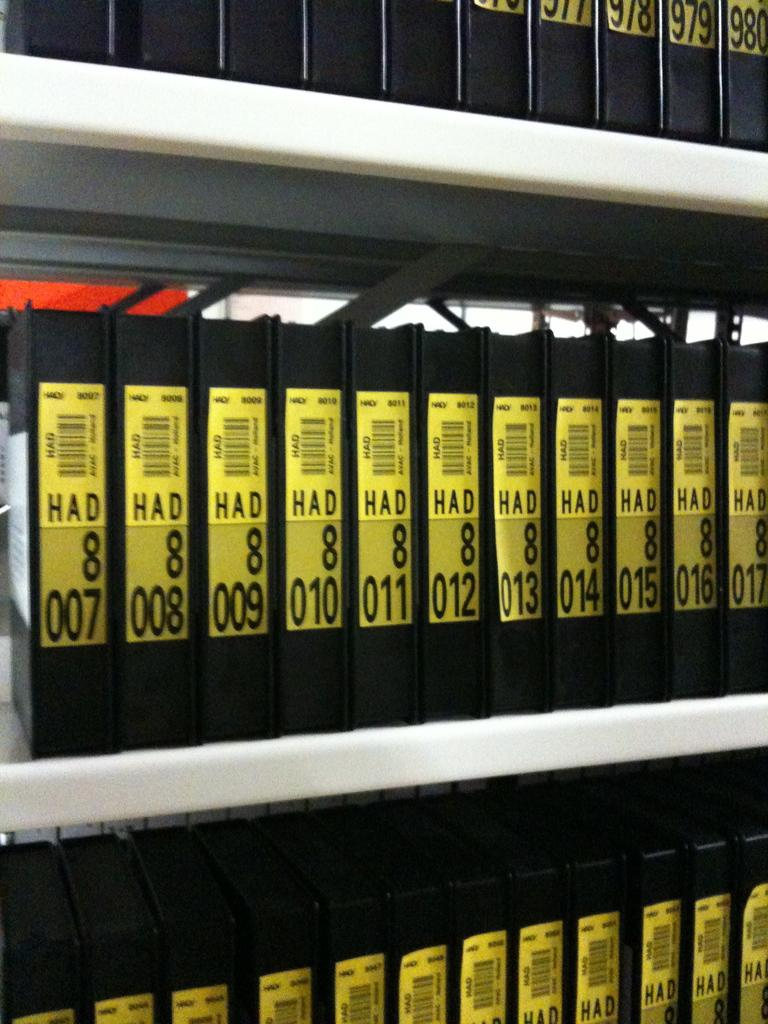What objects can be seen in the image? There are books in the image. Where are the books located? The books are in a bookshelf. What type of lumber is being used to build the bookshelf in the image? There is no information about the type of lumber used to build the bookshelf in the image. 